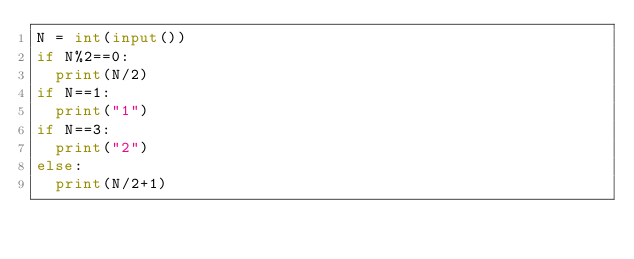Convert code to text. <code><loc_0><loc_0><loc_500><loc_500><_Python_>N = int(input())
if N%2==0:
  print(N/2)
if N==1:
  print("1")
if N==3:
  print("2")
else:
  print(N/2+1)</code> 